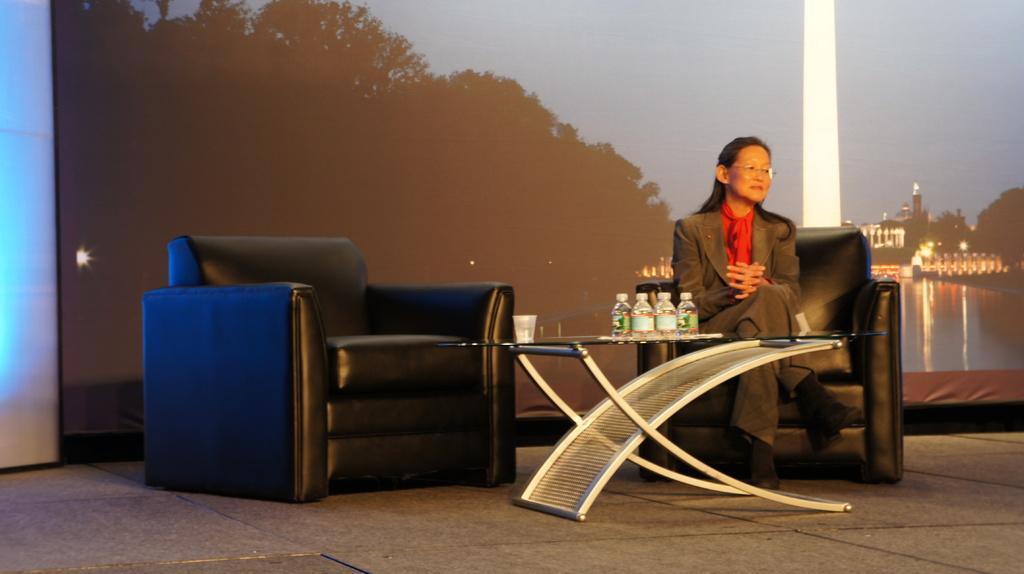Can you describe this image briefly? A lady with black jacket is sitting on a sofa. There is another sofa empty. In front of them there is a table. On the table there are some bottles. In the background there is a screen. In that screen we can see buildings and trees. 